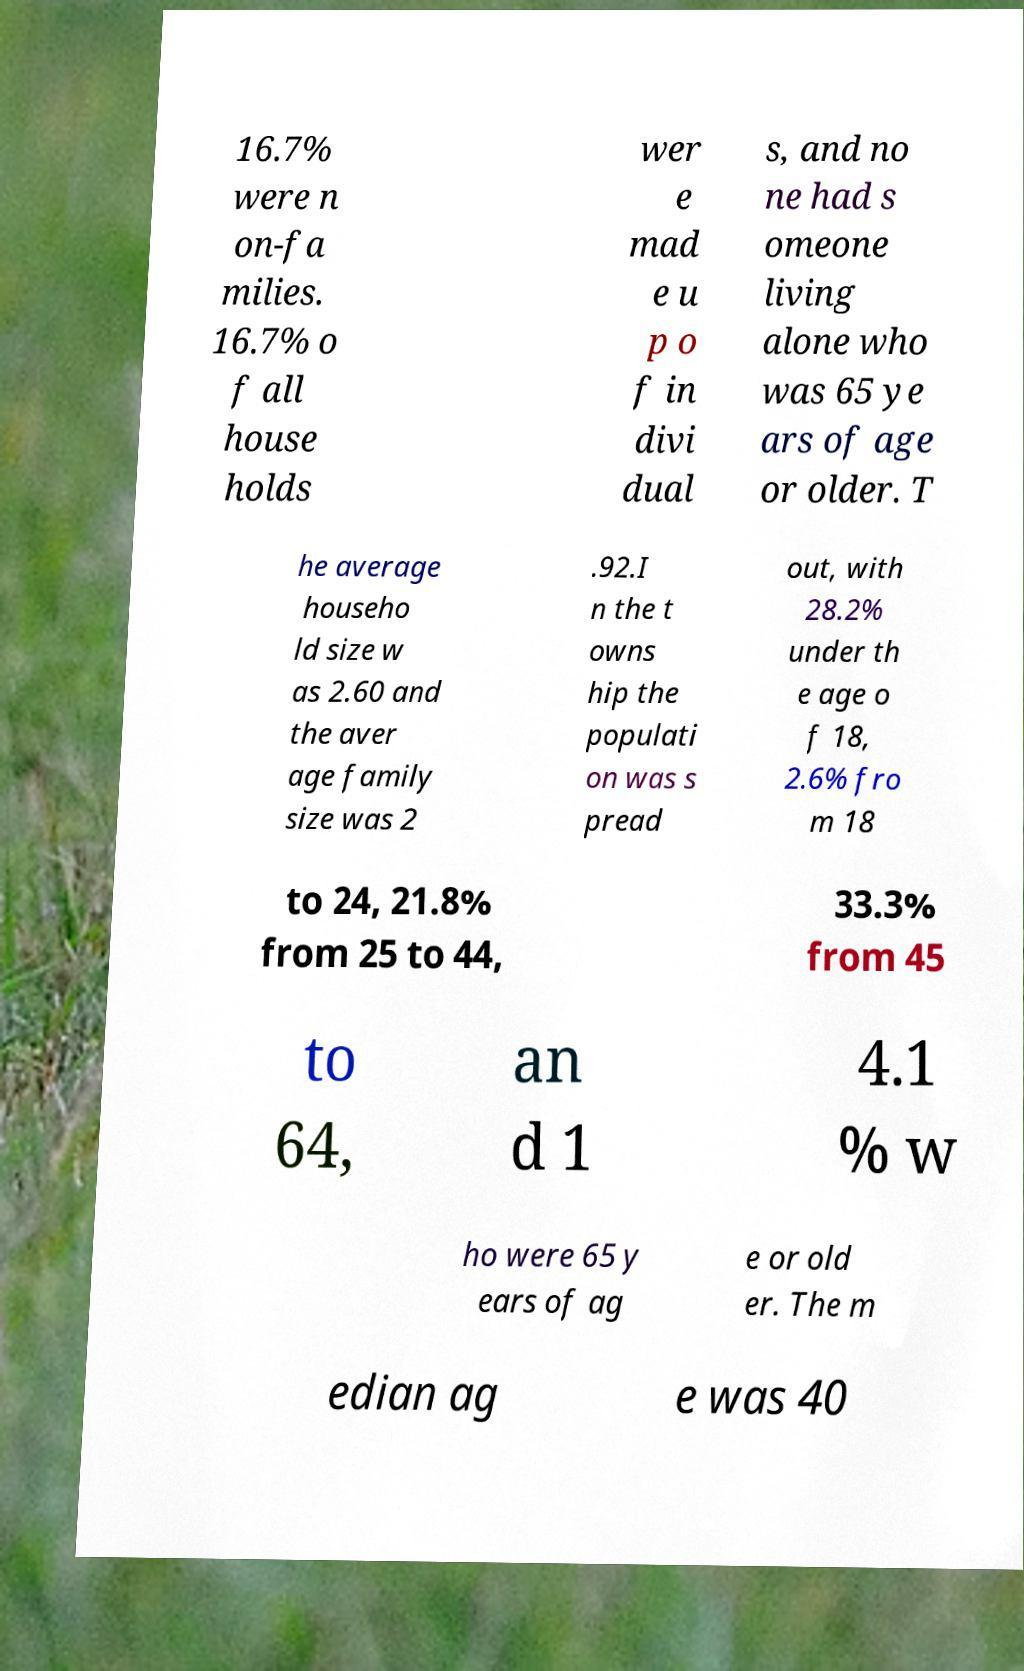Can you accurately transcribe the text from the provided image for me? 16.7% were n on-fa milies. 16.7% o f all house holds wer e mad e u p o f in divi dual s, and no ne had s omeone living alone who was 65 ye ars of age or older. T he average househo ld size w as 2.60 and the aver age family size was 2 .92.I n the t owns hip the populati on was s pread out, with 28.2% under th e age o f 18, 2.6% fro m 18 to 24, 21.8% from 25 to 44, 33.3% from 45 to 64, an d 1 4.1 % w ho were 65 y ears of ag e or old er. The m edian ag e was 40 